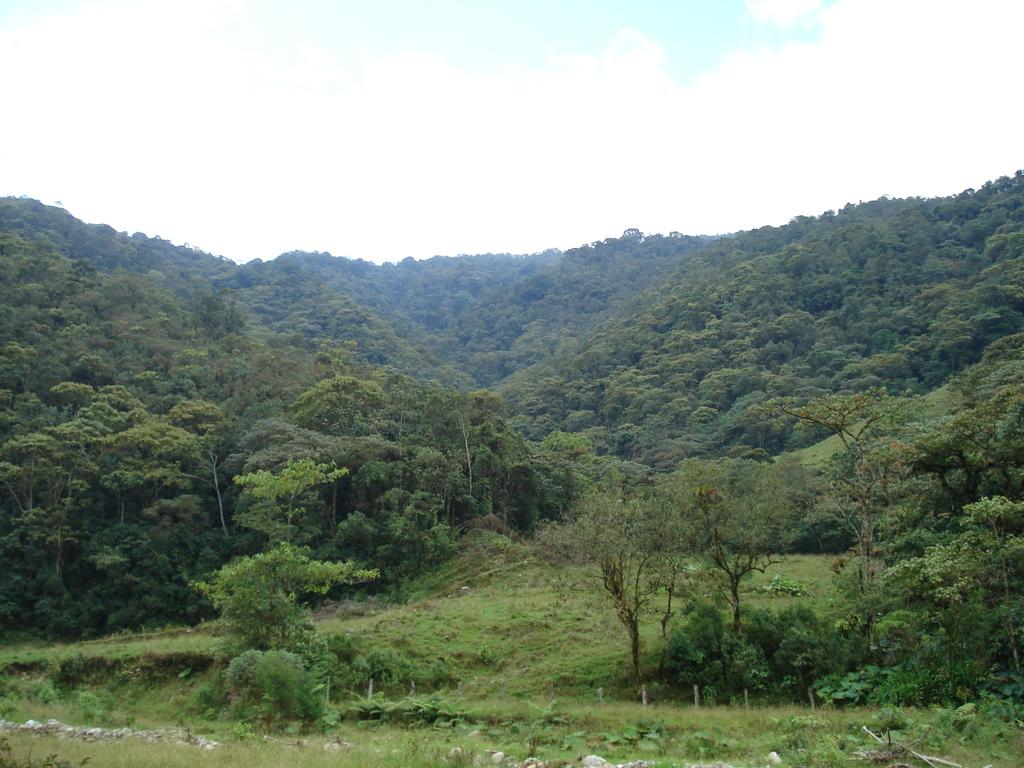What type of vegetation can be seen in the image? There are trees in the image. What geographical feature is visible in the background? There are mountains in the image. What is the ground covered with in the image? The ground is covered in greenery. What type of punishment is being handed out in the image? There is no indication of punishment in the image; it features trees, mountains, and greenery. 